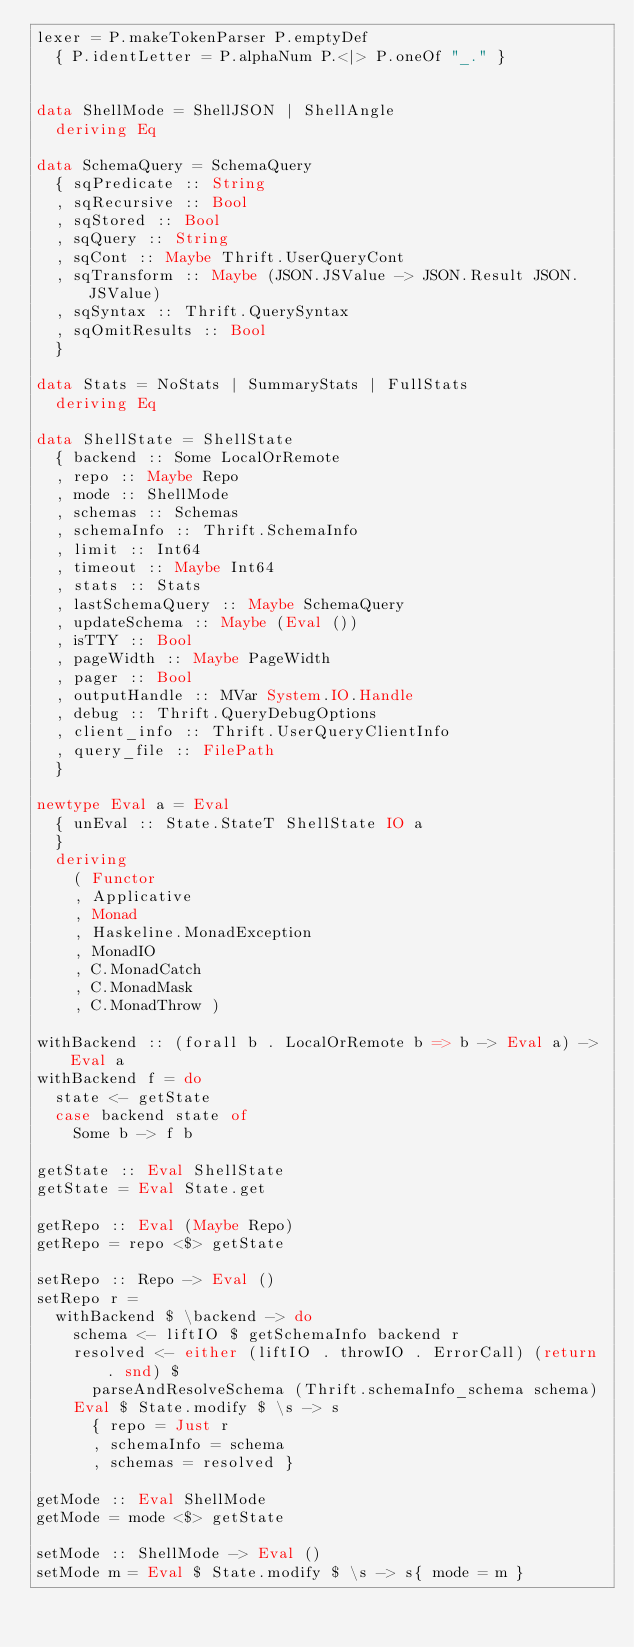Convert code to text. <code><loc_0><loc_0><loc_500><loc_500><_Haskell_>lexer = P.makeTokenParser P.emptyDef
  { P.identLetter = P.alphaNum P.<|> P.oneOf "_." }


data ShellMode = ShellJSON | ShellAngle
  deriving Eq

data SchemaQuery = SchemaQuery
  { sqPredicate :: String
  , sqRecursive :: Bool
  , sqStored :: Bool
  , sqQuery :: String
  , sqCont :: Maybe Thrift.UserQueryCont
  , sqTransform :: Maybe (JSON.JSValue -> JSON.Result JSON.JSValue)
  , sqSyntax :: Thrift.QuerySyntax
  , sqOmitResults :: Bool
  }

data Stats = NoStats | SummaryStats | FullStats
  deriving Eq

data ShellState = ShellState
  { backend :: Some LocalOrRemote
  , repo :: Maybe Repo
  , mode :: ShellMode
  , schemas :: Schemas
  , schemaInfo :: Thrift.SchemaInfo
  , limit :: Int64
  , timeout :: Maybe Int64
  , stats :: Stats
  , lastSchemaQuery :: Maybe SchemaQuery
  , updateSchema :: Maybe (Eval ())
  , isTTY :: Bool
  , pageWidth :: Maybe PageWidth
  , pager :: Bool
  , outputHandle :: MVar System.IO.Handle
  , debug :: Thrift.QueryDebugOptions
  , client_info :: Thrift.UserQueryClientInfo
  , query_file :: FilePath
  }

newtype Eval a = Eval
  { unEval :: State.StateT ShellState IO a
  }
  deriving
    ( Functor
    , Applicative
    , Monad
    , Haskeline.MonadException
    , MonadIO
    , C.MonadCatch
    , C.MonadMask
    , C.MonadThrow )

withBackend :: (forall b . LocalOrRemote b => b -> Eval a) -> Eval a
withBackend f = do
  state <- getState
  case backend state of
    Some b -> f b

getState :: Eval ShellState
getState = Eval State.get

getRepo :: Eval (Maybe Repo)
getRepo = repo <$> getState

setRepo :: Repo -> Eval ()
setRepo r =
  withBackend $ \backend -> do
    schema <- liftIO $ getSchemaInfo backend r
    resolved <- either (liftIO . throwIO . ErrorCall) (return . snd) $
      parseAndResolveSchema (Thrift.schemaInfo_schema schema)
    Eval $ State.modify $ \s -> s
      { repo = Just r
      , schemaInfo = schema
      , schemas = resolved }

getMode :: Eval ShellMode
getMode = mode <$> getState

setMode :: ShellMode -> Eval ()
setMode m = Eval $ State.modify $ \s -> s{ mode = m }
</code> 